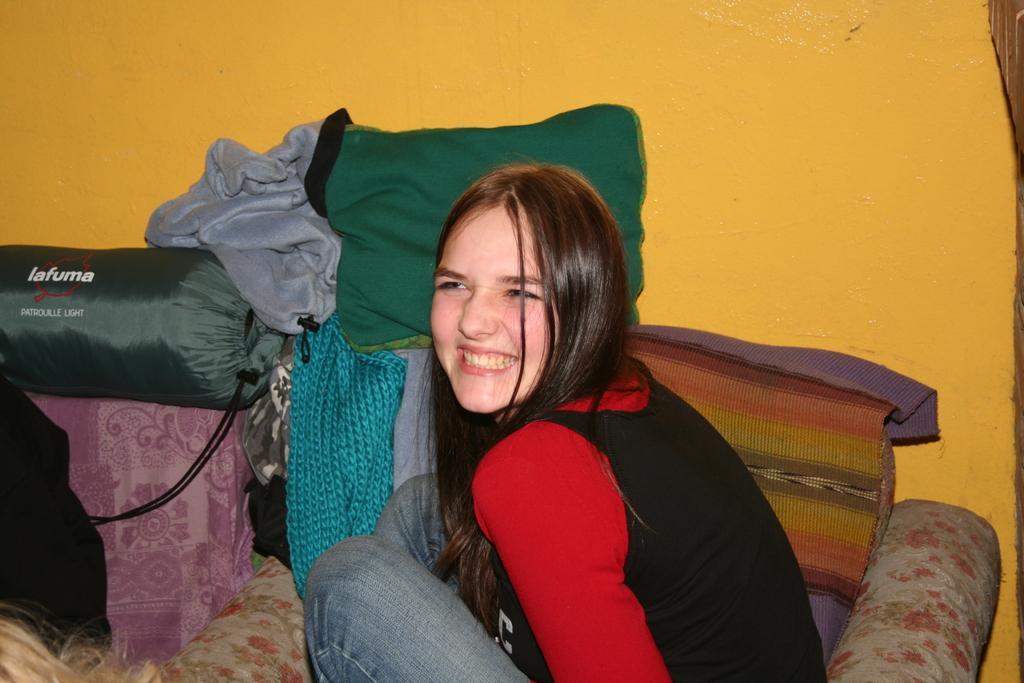Can you describe this image briefly? In this image I can see a woman is sitting on the sofa, cushions and blankets. In the background I can see a orange color wall. This image is taken in a room. 